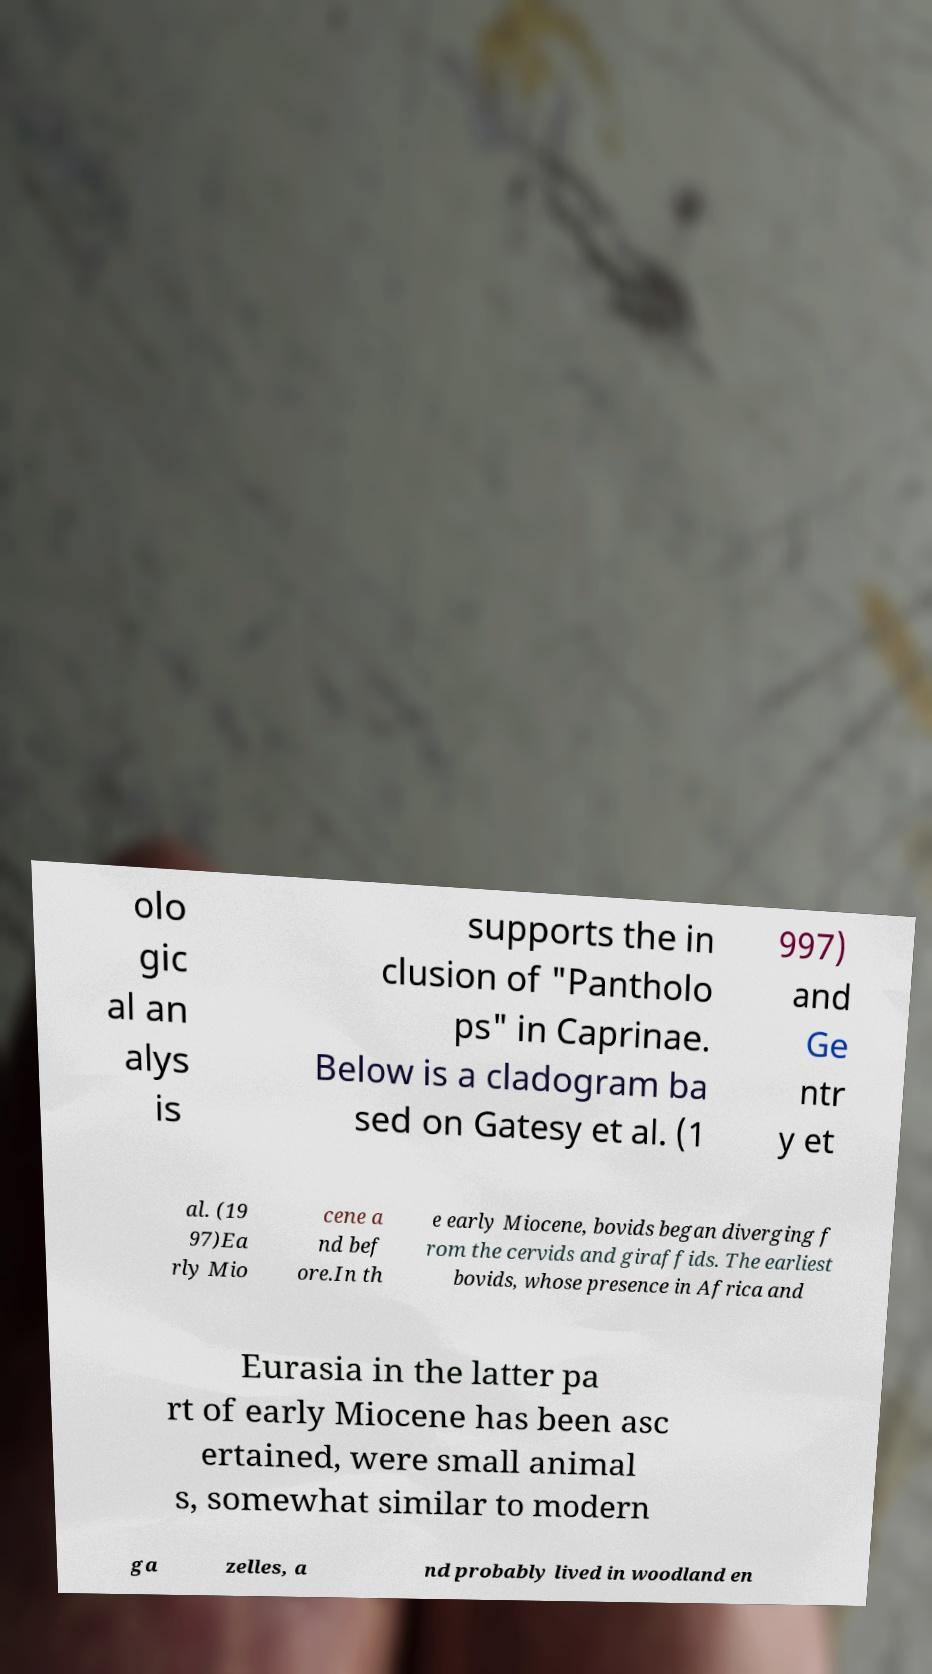There's text embedded in this image that I need extracted. Can you transcribe it verbatim? olo gic al an alys is supports the in clusion of "Pantholo ps" in Caprinae. Below is a cladogram ba sed on Gatesy et al. (1 997) and Ge ntr y et al. (19 97)Ea rly Mio cene a nd bef ore.In th e early Miocene, bovids began diverging f rom the cervids and giraffids. The earliest bovids, whose presence in Africa and Eurasia in the latter pa rt of early Miocene has been asc ertained, were small animal s, somewhat similar to modern ga zelles, a nd probably lived in woodland en 